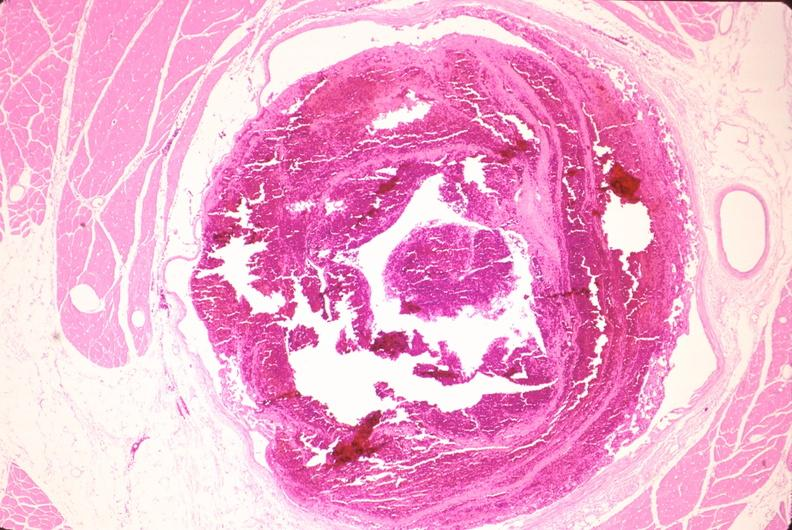what does this image show?
Answer the question using a single word or phrase. Leg veins 